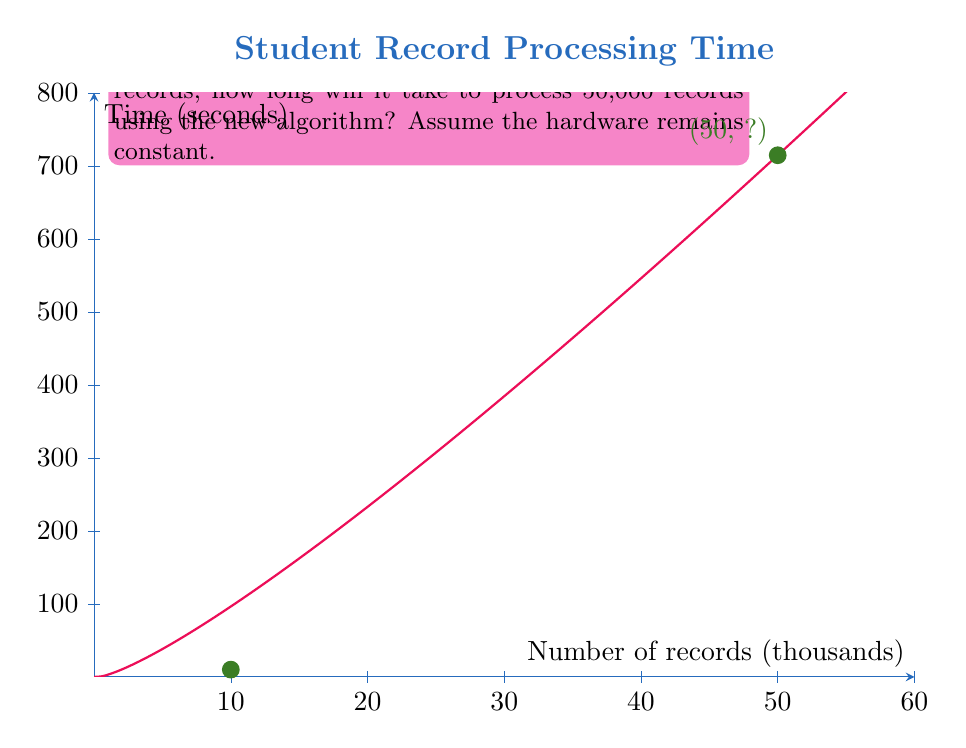Show me your answer to this math problem. Let's approach this step-by-step:

1) First, we need to find the scaling factor between the current system and the new algorithm for 10,000 records.

   Current system: 10 seconds for 10,000 records
   New algorithm: $T(10000) = 2(10000)\log(10000) + 3(10000)$

2) Calculate $T(10000)$:
   $$T(10000) = 20000\log(10000) + 30000$$
   $$= 20000 * 13.2877 + 30000 = 295754$$

3) Find the scaling factor:
   $$\text{Scaling factor} = \frac{10}{295754} = 0.0000338$$

4) Now, calculate $T(50000)$ for the new algorithm:
   $$T(50000) = 2(50000)\log(50000) + 3(50000)$$
   $$= 100000\log(50000) + 150000$$
   $$= 100000 * 15.6096 + 150000 = 1710960$$

5) Apply the scaling factor to get the actual time:
   $$\text{Actual time} = 1710960 * 0.0000338 = 57.83 \text{ seconds}$$

Therefore, it will take approximately 57.83 seconds to process 50,000 records using the new algorithm.
Answer: 57.83 seconds 